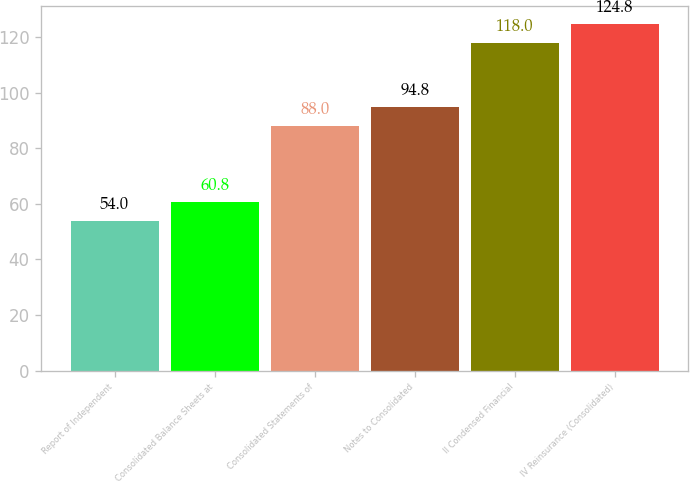Convert chart to OTSL. <chart><loc_0><loc_0><loc_500><loc_500><bar_chart><fcel>Report of Independent<fcel>Consolidated Balance Sheets at<fcel>Consolidated Statements of<fcel>Notes to Consolidated<fcel>II Condensed Financial<fcel>IV Reinsurance (Consolidated)<nl><fcel>54<fcel>60.8<fcel>88<fcel>94.8<fcel>118<fcel>124.8<nl></chart> 